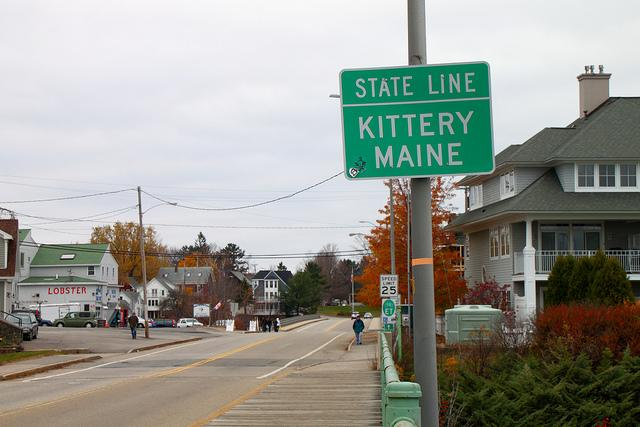What large body of water is nearest this location? Please explain your reasoning. atlantic ocean. Maine is on the east coast of the united states. 